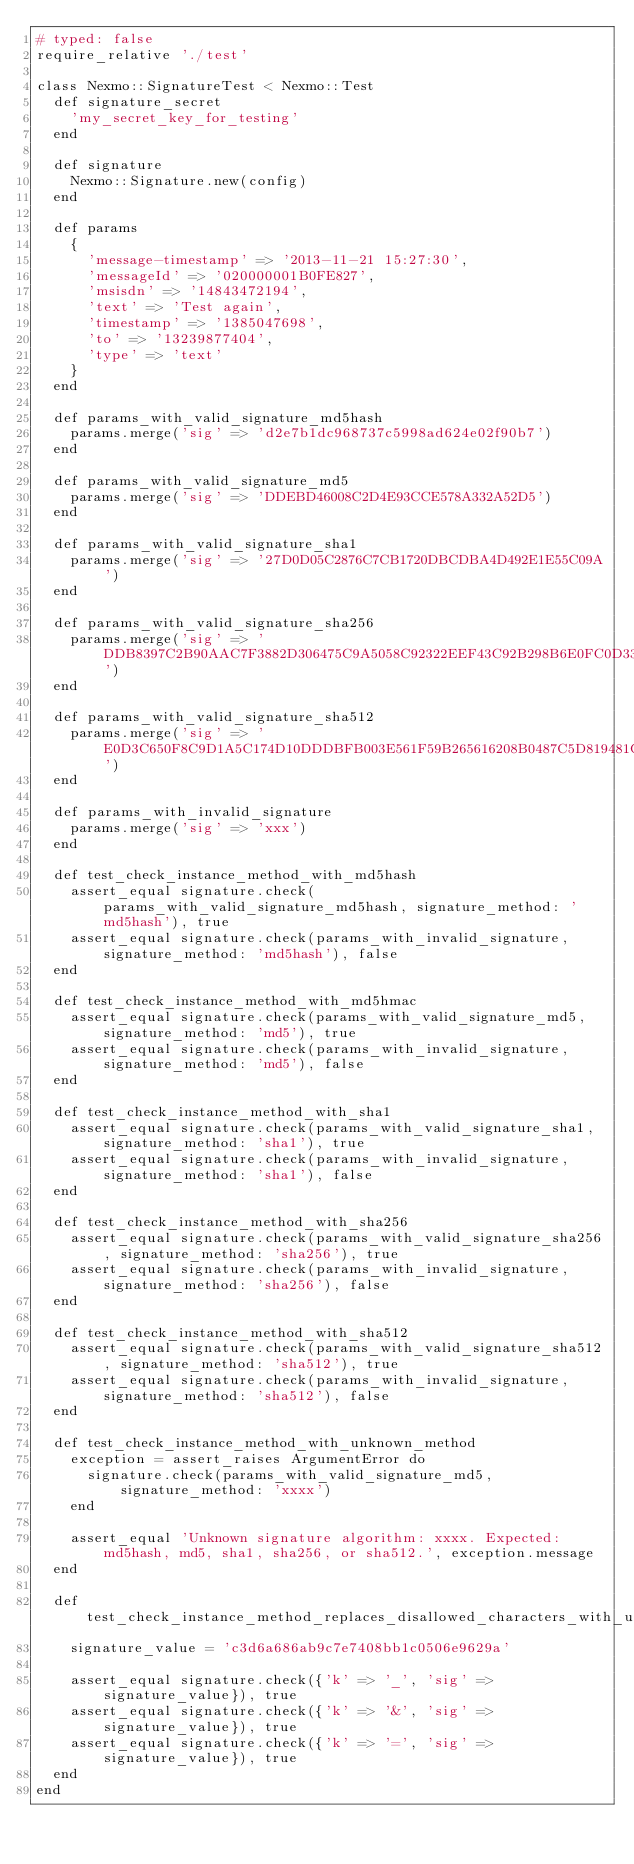<code> <loc_0><loc_0><loc_500><loc_500><_Ruby_># typed: false
require_relative './test'

class Nexmo::SignatureTest < Nexmo::Test
  def signature_secret
    'my_secret_key_for_testing'
  end

  def signature
    Nexmo::Signature.new(config)
  end

  def params
    {
      'message-timestamp' => '2013-11-21 15:27:30',
      'messageId' => '020000001B0FE827',
      'msisdn' => '14843472194',
      'text' => 'Test again',
      'timestamp' => '1385047698',
      'to' => '13239877404',
      'type' => 'text'
    }
  end

  def params_with_valid_signature_md5hash
    params.merge('sig' => 'd2e7b1dc968737c5998ad624e02f90b7')
  end

  def params_with_valid_signature_md5
    params.merge('sig' => 'DDEBD46008C2D4E93CCE578A332A52D5')
  end

  def params_with_valid_signature_sha1
    params.merge('sig' => '27D0D05C2876C7CB1720DBCDBA4D492E1E55C09A')
  end

  def params_with_valid_signature_sha256
    params.merge('sig' => 'DDB8397C2B90AAC7F3882D306475C9A5058C92322EEF43C92B298B6E0FC0D330')
  end

  def params_with_valid_signature_sha512
    params.merge('sig' => 'E0D3C650F8C9D1A5C174D10DDDBFB003E561F59B265616208B0487C5D819481CD3C311D59CF6165ECD1139622D5BA3A256C0D763AC4A9AD9144B5A426B94FE82')
  end

  def params_with_invalid_signature
    params.merge('sig' => 'xxx')
  end

  def test_check_instance_method_with_md5hash
    assert_equal signature.check(params_with_valid_signature_md5hash, signature_method: 'md5hash'), true
    assert_equal signature.check(params_with_invalid_signature, signature_method: 'md5hash'), false
  end

  def test_check_instance_method_with_md5hmac
    assert_equal signature.check(params_with_valid_signature_md5, signature_method: 'md5'), true
    assert_equal signature.check(params_with_invalid_signature, signature_method: 'md5'), false
  end

  def test_check_instance_method_with_sha1
    assert_equal signature.check(params_with_valid_signature_sha1, signature_method: 'sha1'), true
    assert_equal signature.check(params_with_invalid_signature, signature_method: 'sha1'), false
  end

  def test_check_instance_method_with_sha256
    assert_equal signature.check(params_with_valid_signature_sha256, signature_method: 'sha256'), true
    assert_equal signature.check(params_with_invalid_signature, signature_method: 'sha256'), false
  end

  def test_check_instance_method_with_sha512
    assert_equal signature.check(params_with_valid_signature_sha512, signature_method: 'sha512'), true
    assert_equal signature.check(params_with_invalid_signature, signature_method: 'sha512'), false
  end

  def test_check_instance_method_with_unknown_method
    exception = assert_raises ArgumentError do
      signature.check(params_with_valid_signature_md5, signature_method: 'xxxx')
    end

    assert_equal 'Unknown signature algorithm: xxxx. Expected: md5hash, md5, sha1, sha256, or sha512.', exception.message
  end

  def test_check_instance_method_replaces_disallowed_characters_with_underscores
    signature_value = 'c3d6a686ab9c7e7408bb1c0506e9629a'

    assert_equal signature.check({'k' => '_', 'sig' => signature_value}), true
    assert_equal signature.check({'k' => '&', 'sig' => signature_value}), true
    assert_equal signature.check({'k' => '=', 'sig' => signature_value}), true
  end
end
</code> 